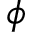Convert formula to latex. <formula><loc_0><loc_0><loc_500><loc_500>\phi</formula> 